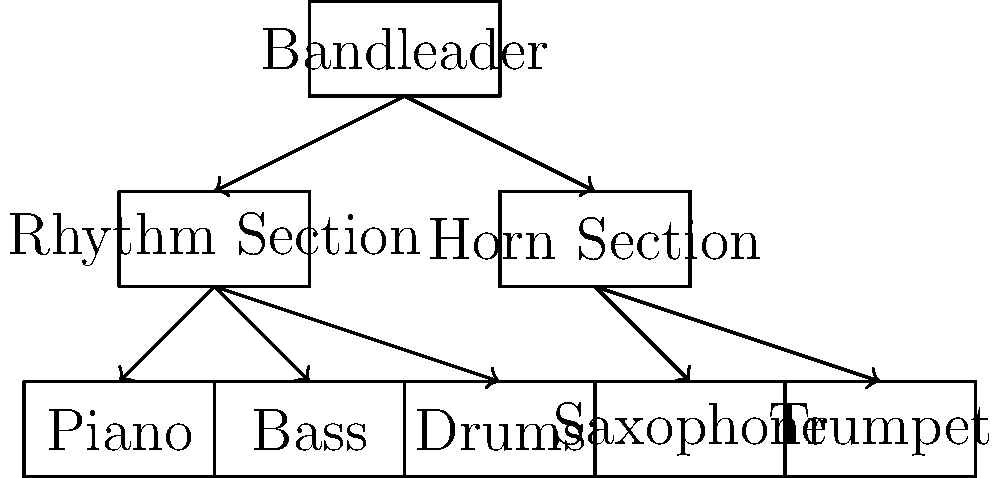In the organizational chart of a typical jazz ensemble, which section is responsible for maintaining the harmonic and rhythmic foundation of the music, and what instruments are usually included in this section? To answer this question, let's analyze the organizational chart of a typical jazz ensemble:

1. The chart shows two main sections under the Bandleader: the Rhythm Section and the Horn Section.

2. The Rhythm Section includes three instruments: Piano, Bass, and Drums.

3. The Horn Section includes two instruments: Saxophone and Trumpet.

4. The Rhythm Section is responsible for maintaining the harmonic and rhythmic foundation of the music. This is because:
   a. The piano provides harmonic support and can also contribute to the rhythm.
   b. The bass establishes the harmonic root and provides a steady rhythmic pulse.
   c. The drums maintain the rhythmic structure and drive of the music.

5. The Horn Section, on the other hand, typically plays the melody and provides solos, but does not primarily focus on maintaining the rhythmic and harmonic foundation.

Therefore, the Rhythm Section, consisting of Piano, Bass, and Drums, is responsible for maintaining the harmonic and rhythmic foundation of the music in a typical jazz ensemble.
Answer: Rhythm Section (Piano, Bass, Drums) 